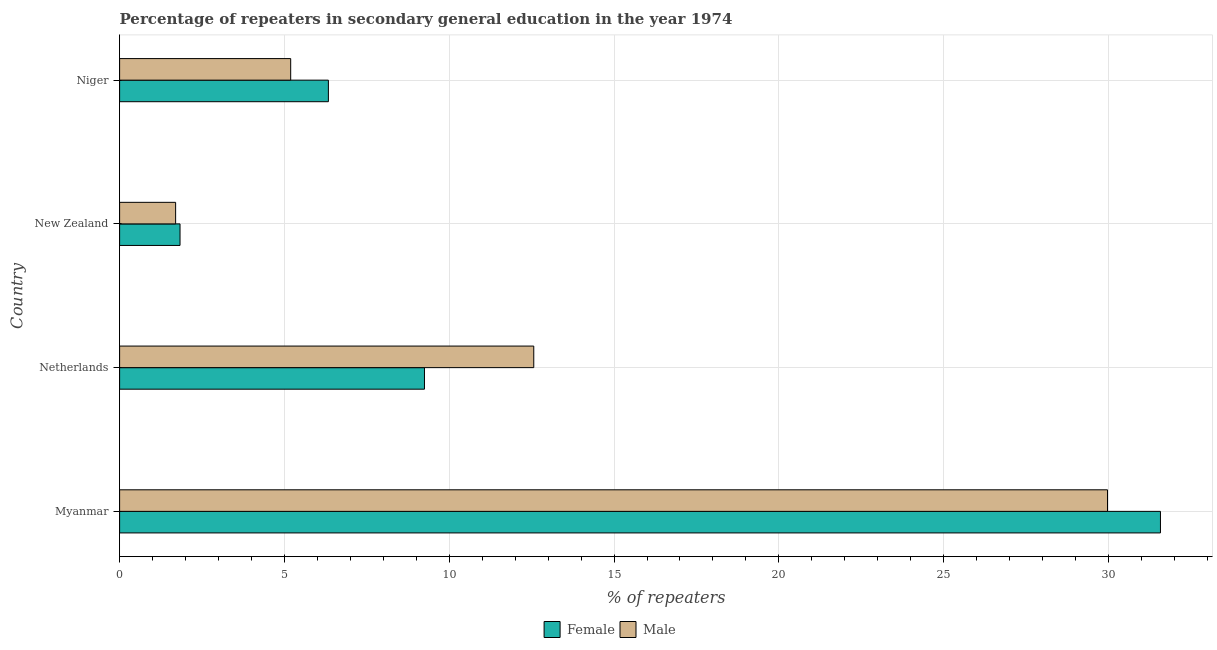How many different coloured bars are there?
Give a very brief answer. 2. How many groups of bars are there?
Provide a succinct answer. 4. Are the number of bars per tick equal to the number of legend labels?
Your answer should be very brief. Yes. Are the number of bars on each tick of the Y-axis equal?
Ensure brevity in your answer.  Yes. What is the label of the 3rd group of bars from the top?
Give a very brief answer. Netherlands. In how many cases, is the number of bars for a given country not equal to the number of legend labels?
Keep it short and to the point. 0. What is the percentage of female repeaters in Netherlands?
Your response must be concise. 9.25. Across all countries, what is the maximum percentage of female repeaters?
Provide a succinct answer. 31.58. Across all countries, what is the minimum percentage of male repeaters?
Provide a succinct answer. 1.7. In which country was the percentage of female repeaters maximum?
Give a very brief answer. Myanmar. In which country was the percentage of male repeaters minimum?
Make the answer very short. New Zealand. What is the total percentage of female repeaters in the graph?
Give a very brief answer. 48.99. What is the difference between the percentage of female repeaters in Netherlands and that in New Zealand?
Your answer should be compact. 7.42. What is the difference between the percentage of female repeaters in Netherlands and the percentage of male repeaters in Niger?
Ensure brevity in your answer.  4.06. What is the average percentage of female repeaters per country?
Give a very brief answer. 12.25. What is the difference between the percentage of female repeaters and percentage of male repeaters in Netherlands?
Provide a short and direct response. -3.32. What is the ratio of the percentage of male repeaters in Netherlands to that in Niger?
Ensure brevity in your answer.  2.42. Is the percentage of female repeaters in Netherlands less than that in New Zealand?
Make the answer very short. No. What is the difference between the highest and the second highest percentage of male repeaters?
Offer a terse response. 17.41. What is the difference between the highest and the lowest percentage of male repeaters?
Offer a very short reply. 28.27. Is the sum of the percentage of female repeaters in Netherlands and New Zealand greater than the maximum percentage of male repeaters across all countries?
Ensure brevity in your answer.  No. What does the 2nd bar from the top in New Zealand represents?
Your answer should be compact. Female. How many bars are there?
Your response must be concise. 8. Are all the bars in the graph horizontal?
Keep it short and to the point. Yes. Are the values on the major ticks of X-axis written in scientific E-notation?
Offer a very short reply. No. Does the graph contain any zero values?
Your response must be concise. No. Does the graph contain grids?
Keep it short and to the point. Yes. Where does the legend appear in the graph?
Your response must be concise. Bottom center. How many legend labels are there?
Ensure brevity in your answer.  2. How are the legend labels stacked?
Your response must be concise. Horizontal. What is the title of the graph?
Ensure brevity in your answer.  Percentage of repeaters in secondary general education in the year 1974. What is the label or title of the X-axis?
Ensure brevity in your answer.  % of repeaters. What is the % of repeaters in Female in Myanmar?
Provide a succinct answer. 31.58. What is the % of repeaters in Male in Myanmar?
Your response must be concise. 29.97. What is the % of repeaters of Female in Netherlands?
Make the answer very short. 9.25. What is the % of repeaters of Male in Netherlands?
Keep it short and to the point. 12.56. What is the % of repeaters in Female in New Zealand?
Offer a very short reply. 1.83. What is the % of repeaters in Male in New Zealand?
Your answer should be compact. 1.7. What is the % of repeaters of Female in Niger?
Keep it short and to the point. 6.33. What is the % of repeaters of Male in Niger?
Your answer should be very brief. 5.19. Across all countries, what is the maximum % of repeaters of Female?
Your answer should be very brief. 31.58. Across all countries, what is the maximum % of repeaters of Male?
Make the answer very short. 29.97. Across all countries, what is the minimum % of repeaters in Female?
Provide a succinct answer. 1.83. Across all countries, what is the minimum % of repeaters in Male?
Offer a very short reply. 1.7. What is the total % of repeaters of Female in the graph?
Provide a short and direct response. 48.99. What is the total % of repeaters in Male in the graph?
Your answer should be very brief. 49.43. What is the difference between the % of repeaters of Female in Myanmar and that in Netherlands?
Offer a terse response. 22.33. What is the difference between the % of repeaters in Male in Myanmar and that in Netherlands?
Keep it short and to the point. 17.41. What is the difference between the % of repeaters in Female in Myanmar and that in New Zealand?
Ensure brevity in your answer.  29.74. What is the difference between the % of repeaters of Male in Myanmar and that in New Zealand?
Offer a very short reply. 28.27. What is the difference between the % of repeaters of Female in Myanmar and that in Niger?
Your response must be concise. 25.24. What is the difference between the % of repeaters in Male in Myanmar and that in Niger?
Your response must be concise. 24.78. What is the difference between the % of repeaters in Female in Netherlands and that in New Zealand?
Provide a succinct answer. 7.42. What is the difference between the % of repeaters of Male in Netherlands and that in New Zealand?
Offer a terse response. 10.87. What is the difference between the % of repeaters in Female in Netherlands and that in Niger?
Keep it short and to the point. 2.91. What is the difference between the % of repeaters in Male in Netherlands and that in Niger?
Make the answer very short. 7.37. What is the difference between the % of repeaters in Female in New Zealand and that in Niger?
Offer a very short reply. -4.5. What is the difference between the % of repeaters in Male in New Zealand and that in Niger?
Your response must be concise. -3.49. What is the difference between the % of repeaters in Female in Myanmar and the % of repeaters in Male in Netherlands?
Provide a short and direct response. 19.01. What is the difference between the % of repeaters of Female in Myanmar and the % of repeaters of Male in New Zealand?
Your answer should be compact. 29.88. What is the difference between the % of repeaters of Female in Myanmar and the % of repeaters of Male in Niger?
Keep it short and to the point. 26.39. What is the difference between the % of repeaters of Female in Netherlands and the % of repeaters of Male in New Zealand?
Keep it short and to the point. 7.55. What is the difference between the % of repeaters of Female in Netherlands and the % of repeaters of Male in Niger?
Provide a short and direct response. 4.06. What is the difference between the % of repeaters in Female in New Zealand and the % of repeaters in Male in Niger?
Your response must be concise. -3.36. What is the average % of repeaters of Female per country?
Offer a very short reply. 12.25. What is the average % of repeaters of Male per country?
Your answer should be very brief. 12.36. What is the difference between the % of repeaters in Female and % of repeaters in Male in Myanmar?
Keep it short and to the point. 1.61. What is the difference between the % of repeaters of Female and % of repeaters of Male in Netherlands?
Provide a succinct answer. -3.32. What is the difference between the % of repeaters of Female and % of repeaters of Male in New Zealand?
Provide a succinct answer. 0.13. What is the difference between the % of repeaters of Female and % of repeaters of Male in Niger?
Offer a terse response. 1.14. What is the ratio of the % of repeaters in Female in Myanmar to that in Netherlands?
Your answer should be compact. 3.41. What is the ratio of the % of repeaters in Male in Myanmar to that in Netherlands?
Provide a succinct answer. 2.39. What is the ratio of the % of repeaters in Female in Myanmar to that in New Zealand?
Offer a terse response. 17.22. What is the ratio of the % of repeaters in Male in Myanmar to that in New Zealand?
Make the answer very short. 17.64. What is the ratio of the % of repeaters in Female in Myanmar to that in Niger?
Keep it short and to the point. 4.99. What is the ratio of the % of repeaters in Male in Myanmar to that in Niger?
Offer a very short reply. 5.77. What is the ratio of the % of repeaters of Female in Netherlands to that in New Zealand?
Provide a short and direct response. 5.04. What is the ratio of the % of repeaters in Male in Netherlands to that in New Zealand?
Provide a succinct answer. 7.39. What is the ratio of the % of repeaters of Female in Netherlands to that in Niger?
Your answer should be compact. 1.46. What is the ratio of the % of repeaters in Male in Netherlands to that in Niger?
Keep it short and to the point. 2.42. What is the ratio of the % of repeaters in Female in New Zealand to that in Niger?
Ensure brevity in your answer.  0.29. What is the ratio of the % of repeaters of Male in New Zealand to that in Niger?
Your answer should be very brief. 0.33. What is the difference between the highest and the second highest % of repeaters in Female?
Provide a short and direct response. 22.33. What is the difference between the highest and the second highest % of repeaters of Male?
Make the answer very short. 17.41. What is the difference between the highest and the lowest % of repeaters of Female?
Give a very brief answer. 29.74. What is the difference between the highest and the lowest % of repeaters of Male?
Ensure brevity in your answer.  28.27. 